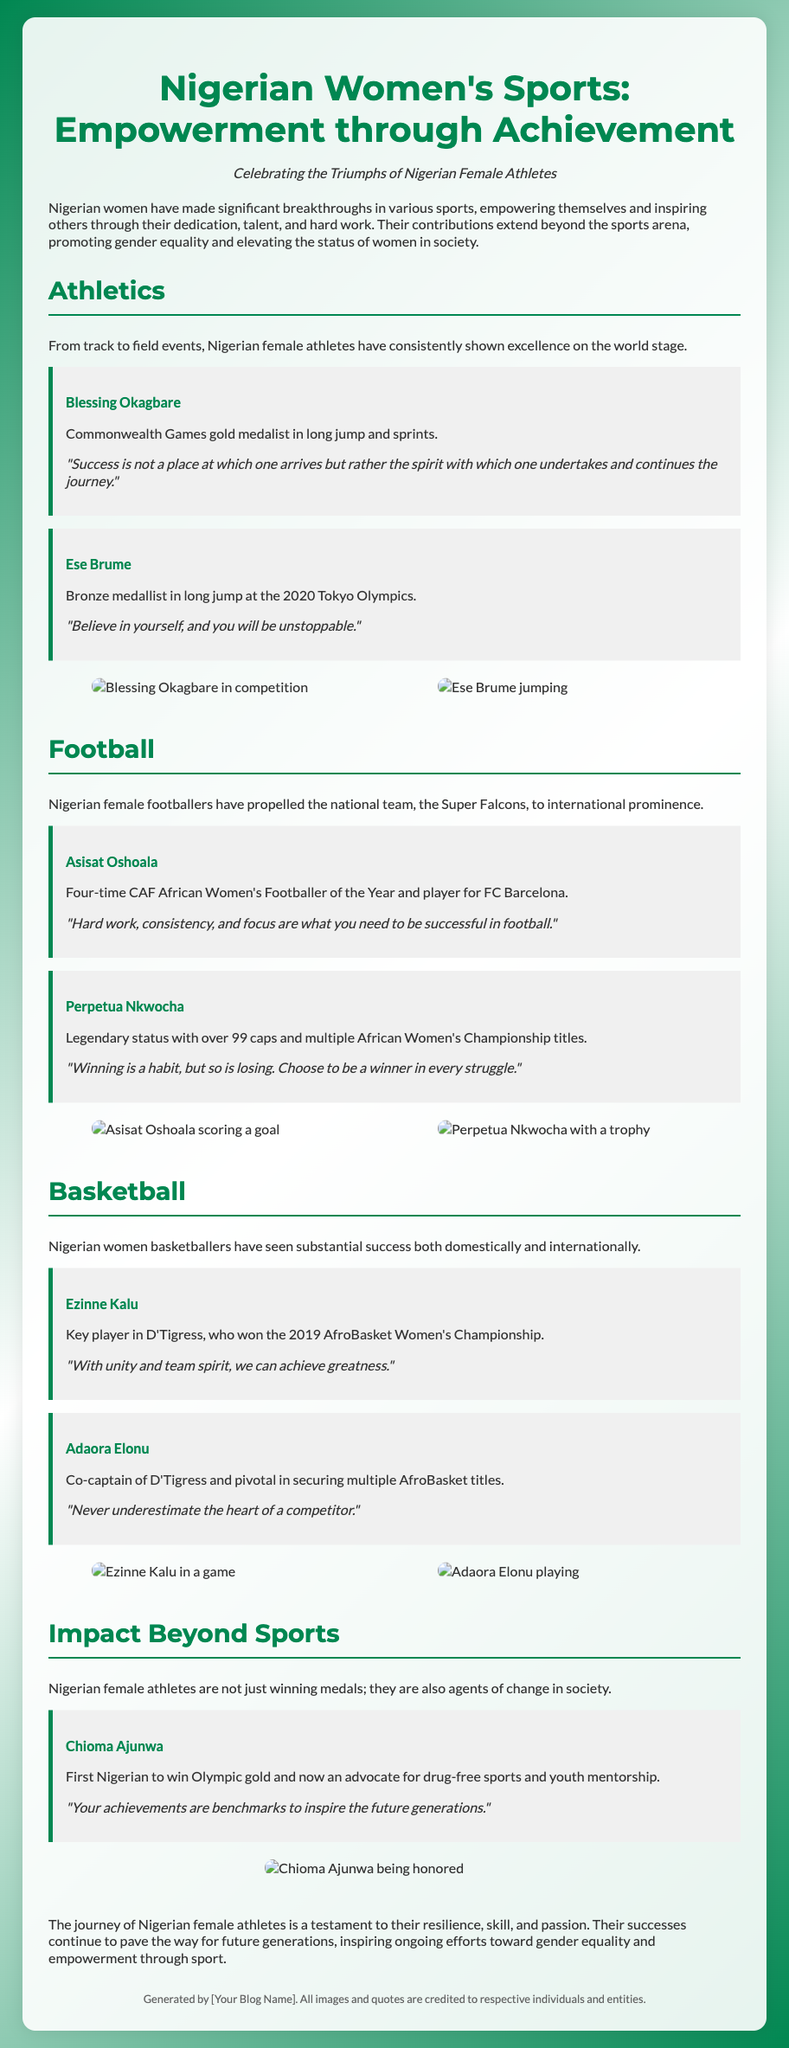What is the title of the poster? The title is prominently displayed at the top of the document.
Answer: Nigerian Women's Sports: Empowerment through Achievement Who is highlighted as the Commonwealth Games gold medalist? This information can be found in the Athletics section of the poster.
Answer: Blessing Okagbare How many times has Asisat Oshoala won the CAF African Women's Footballer of the Year? The specific number is mentioned in the Football section.
Answer: Four times Which athlete is associated with being the first Nigerian to win Olympic gold? This information is found in the Impact Beyond Sports section of the document.
Answer: Chioma Ajunwa What is the main theme of the poster? The theme is suggested through the introductory paragraph of the document.
Answer: Celebrating the Triumphs of Nigerian Female Athletes What sport does Ezinne Kalu play? This can be inferred from the section titled Basketball.
Answer: Basketball What quote is attributed to Ese Brume? The quote is found in the Athletics section.
Answer: "Believe in yourself, and you will be unstoppable." What significant achievement does Perpetua Nkwocha have? This is detailed in the Football section regarding her career.
Answer: Over 99 caps What year did D'Tigress win the AfroBasket Women's Championship? This information is noted in the Basketball section.
Answer: 2019 